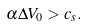Convert formula to latex. <formula><loc_0><loc_0><loc_500><loc_500>\alpha \Delta V _ { 0 } > c _ { s } .</formula> 